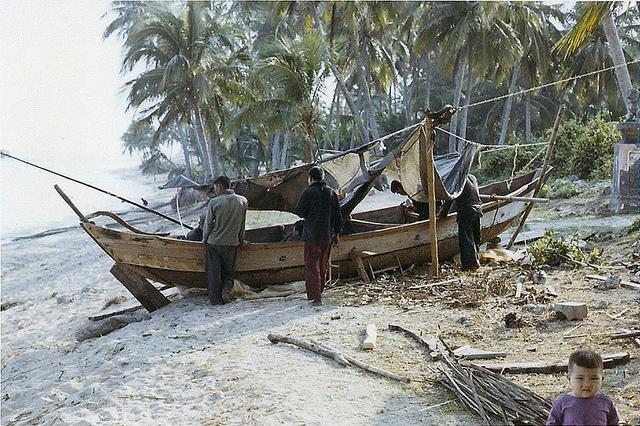Who is in the front right corner? baby 